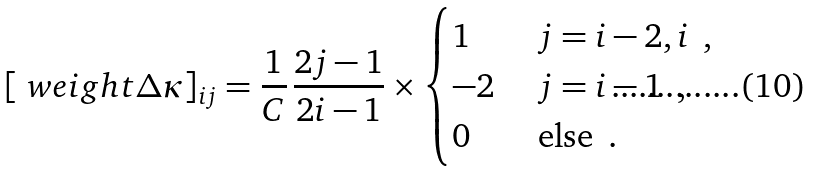<formula> <loc_0><loc_0><loc_500><loc_500>[ \ w e i g h t { \Delta \kappa } ] _ { i j } = \frac { 1 } { C } \, \frac { 2 j - 1 } { 2 i - 1 } \times \begin{cases} 1 & \text { $j=i-2,i$ } \, , \\ - 2 & \text { $j=i-1$  } \, , \\ 0 & \text { else   } \, . \end{cases}</formula> 